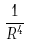<formula> <loc_0><loc_0><loc_500><loc_500>\frac { 1 } { R ^ { 4 } }</formula> 